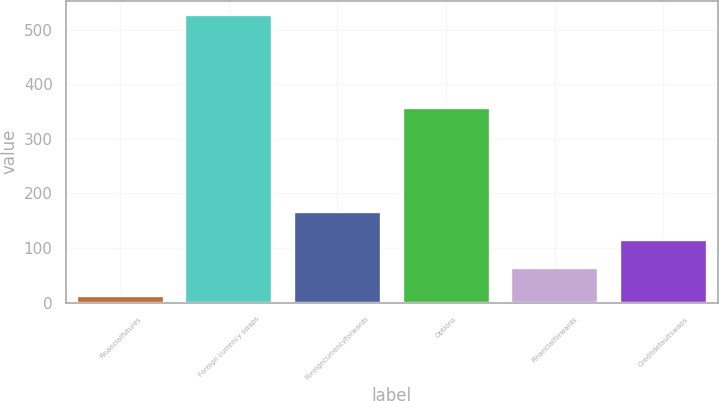Convert chart to OTSL. <chart><loc_0><loc_0><loc_500><loc_500><bar_chart><fcel>Financialfutures<fcel>Foreign currency swaps<fcel>Foreigncurrencyforwards<fcel>Options<fcel>Financialforwards<fcel>Creditdefaultswaps<nl><fcel>12<fcel>527<fcel>166.5<fcel>356<fcel>63.5<fcel>115<nl></chart> 